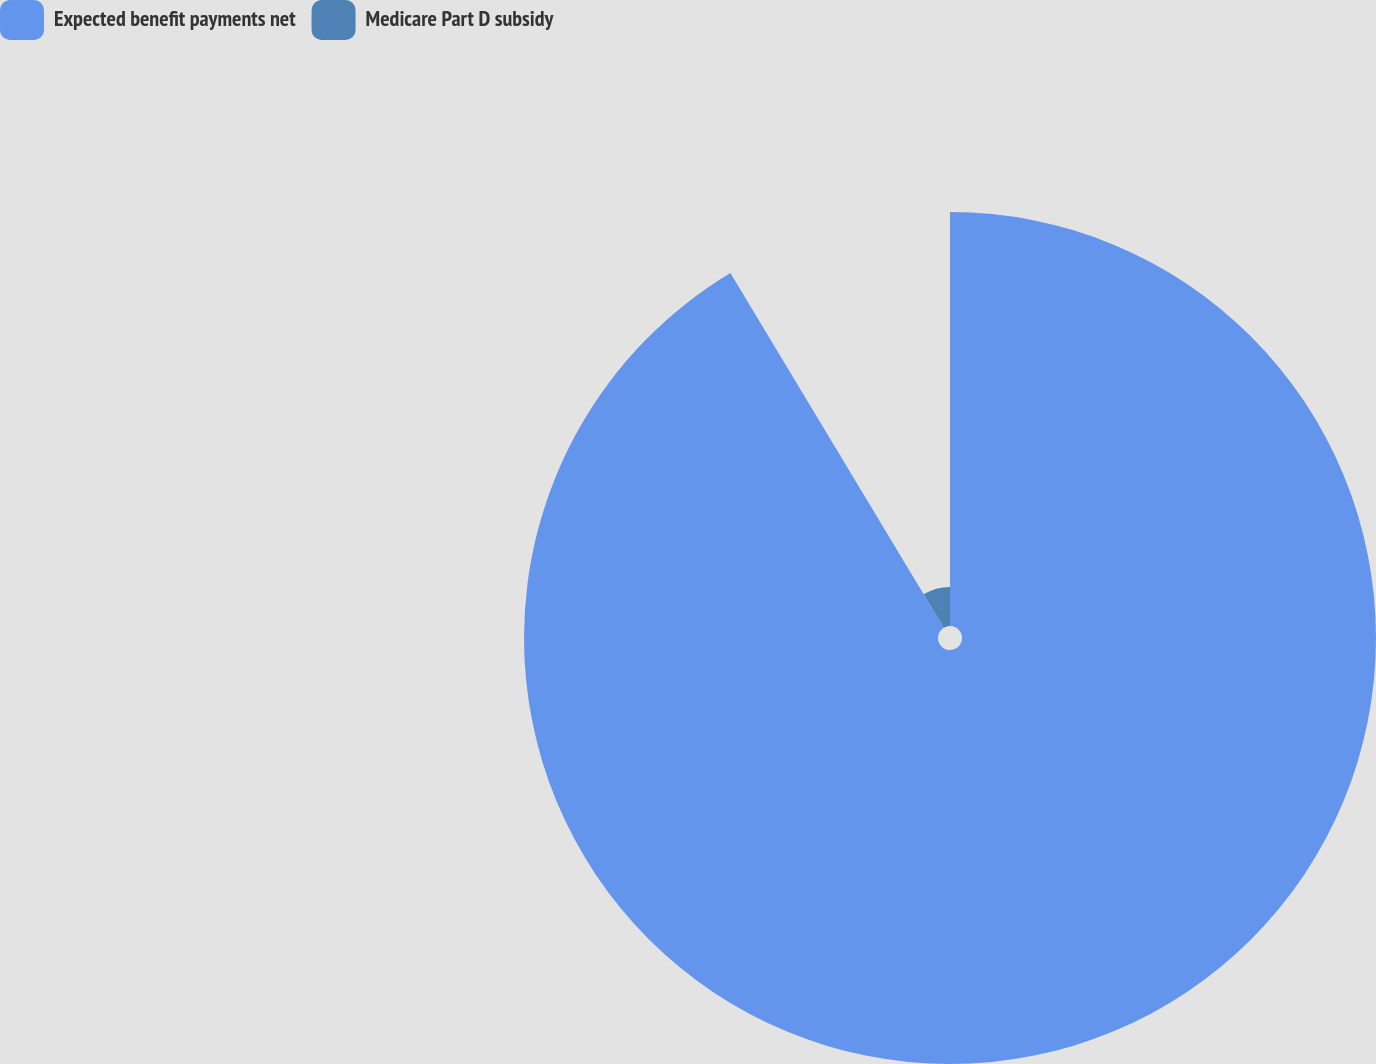Convert chart to OTSL. <chart><loc_0><loc_0><loc_500><loc_500><pie_chart><fcel>Expected benefit payments net<fcel>Medicare Part D subsidy<nl><fcel>91.38%<fcel>8.62%<nl></chart> 